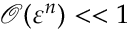<formula> <loc_0><loc_0><loc_500><loc_500>\mathcal { O } ( \varepsilon ^ { n } ) < < 1</formula> 